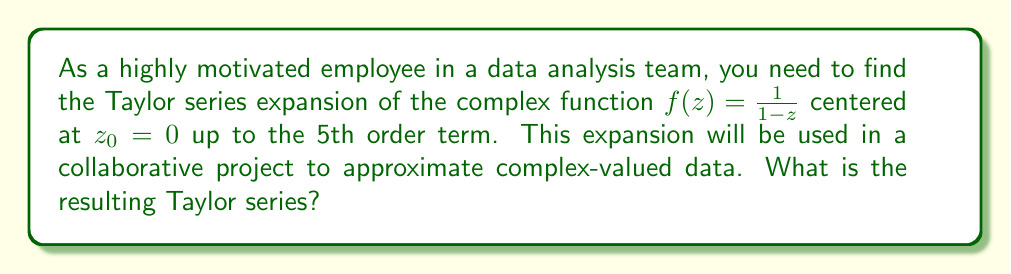Solve this math problem. Let's approach this step-by-step:

1) The general form of a Taylor series expansion for a complex function $f(z)$ centered at $z_0$ is:

   $$f(z) = \sum_{n=0}^{\infty} \frac{f^{(n)}(z_0)}{n!}(z-z_0)^n$$

2) For our function $f(z) = \frac{1}{1-z}$ centered at $z_0 = 0$, we need to find the derivatives up to the 5th order:

   $f(z) = (1-z)^{-1}$
   $f'(z) = (1-z)^{-2}$
   $f''(z) = 2(1-z)^{-3}$
   $f'''(z) = 6(1-z)^{-4}$
   $f^{(4)}(z) = 24(1-z)^{-5}$
   $f^{(5)}(z) = 120(1-z)^{-6}$

3) Now, we evaluate these at $z_0 = 0$:

   $f(0) = 1$
   $f'(0) = 1$
   $f''(0) = 2$
   $f'''(0) = 6$
   $f^{(4)}(0) = 24$
   $f^{(5)}(0) = 120$

4) Substituting these into the Taylor series formula:

   $$f(z) = 1 + \frac{1}{1!}z + \frac{2}{2!}z^2 + \frac{6}{3!}z^3 + \frac{24}{4!}z^4 + \frac{120}{5!}z^5 + O(z^6)$$

5) Simplifying:

   $$f(z) = 1 + z + z^2 + z^3 + z^4 + z^5 + O(z^6)$$

This is the Taylor series expansion of $\frac{1}{1-z}$ up to the 5th order term.
Answer: $1 + z + z^2 + z^3 + z^4 + z^5 + O(z^6)$ 